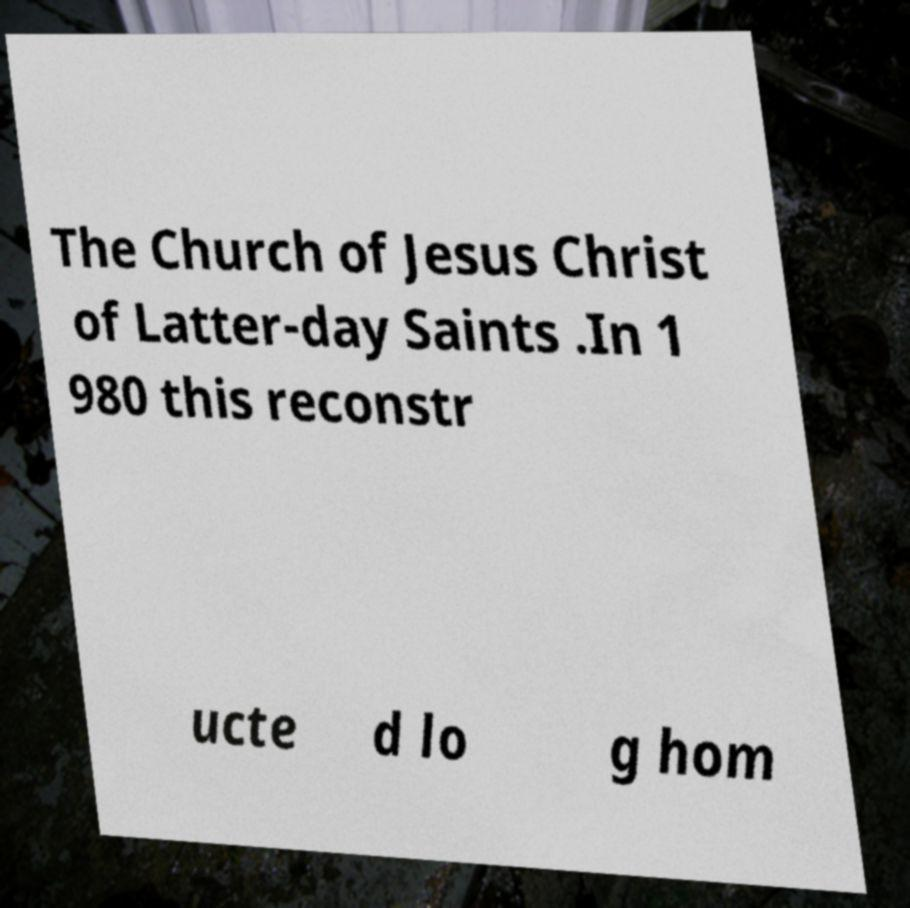Please read and relay the text visible in this image. What does it say? The Church of Jesus Christ of Latter-day Saints .In 1 980 this reconstr ucte d lo g hom 